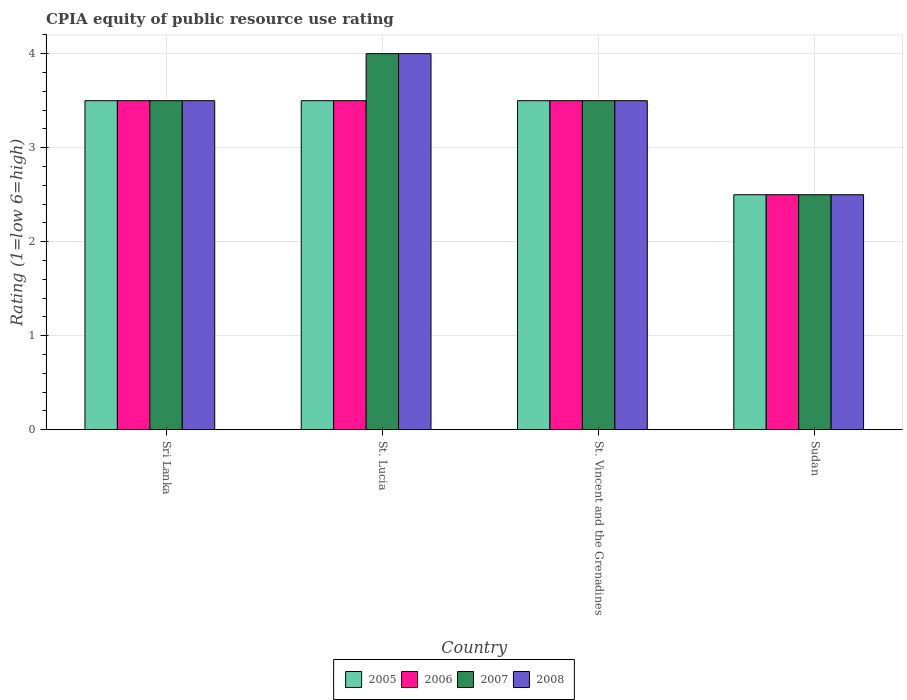How many different coloured bars are there?
Ensure brevity in your answer.  4. What is the label of the 3rd group of bars from the left?
Ensure brevity in your answer.  St. Vincent and the Grenadines. In how many cases, is the number of bars for a given country not equal to the number of legend labels?
Your response must be concise. 0. Across all countries, what is the maximum CPIA rating in 2006?
Offer a very short reply. 3.5. In which country was the CPIA rating in 2006 maximum?
Your answer should be compact. Sri Lanka. In which country was the CPIA rating in 2008 minimum?
Provide a succinct answer. Sudan. What is the total CPIA rating in 2005 in the graph?
Offer a very short reply. 13. What is the difference between the CPIA rating in 2008 in St. Lucia and the CPIA rating in 2007 in Sri Lanka?
Your answer should be very brief. 0.5. What is the average CPIA rating in 2005 per country?
Offer a terse response. 3.25. What is the difference between the highest and the second highest CPIA rating in 2008?
Offer a terse response. -0.5. In how many countries, is the CPIA rating in 2008 greater than the average CPIA rating in 2008 taken over all countries?
Provide a succinct answer. 3. Is it the case that in every country, the sum of the CPIA rating in 2005 and CPIA rating in 2006 is greater than the sum of CPIA rating in 2008 and CPIA rating in 2007?
Ensure brevity in your answer.  No. What does the 3rd bar from the left in Sudan represents?
Your answer should be very brief. 2007. What does the 3rd bar from the right in Sri Lanka represents?
Keep it short and to the point. 2006. Is it the case that in every country, the sum of the CPIA rating in 2007 and CPIA rating in 2008 is greater than the CPIA rating in 2005?
Keep it short and to the point. Yes. Are all the bars in the graph horizontal?
Give a very brief answer. No. How many countries are there in the graph?
Give a very brief answer. 4. What is the difference between two consecutive major ticks on the Y-axis?
Provide a succinct answer. 1. Are the values on the major ticks of Y-axis written in scientific E-notation?
Offer a terse response. No. Does the graph contain any zero values?
Your answer should be very brief. No. Where does the legend appear in the graph?
Ensure brevity in your answer.  Bottom center. How many legend labels are there?
Offer a very short reply. 4. What is the title of the graph?
Make the answer very short. CPIA equity of public resource use rating. What is the label or title of the X-axis?
Provide a succinct answer. Country. What is the Rating (1=low 6=high) in 2008 in Sri Lanka?
Your answer should be compact. 3.5. What is the Rating (1=low 6=high) of 2006 in St. Lucia?
Your response must be concise. 3.5. What is the Rating (1=low 6=high) of 2007 in St. Lucia?
Your response must be concise. 4. What is the Rating (1=low 6=high) in 2006 in St. Vincent and the Grenadines?
Provide a short and direct response. 3.5. What is the Rating (1=low 6=high) of 2007 in St. Vincent and the Grenadines?
Offer a terse response. 3.5. What is the Rating (1=low 6=high) of 2005 in Sudan?
Make the answer very short. 2.5. What is the Rating (1=low 6=high) in 2007 in Sudan?
Offer a very short reply. 2.5. What is the Rating (1=low 6=high) of 2008 in Sudan?
Your answer should be very brief. 2.5. Across all countries, what is the maximum Rating (1=low 6=high) of 2005?
Your answer should be very brief. 3.5. Across all countries, what is the maximum Rating (1=low 6=high) in 2006?
Provide a short and direct response. 3.5. Across all countries, what is the minimum Rating (1=low 6=high) of 2005?
Your answer should be very brief. 2.5. Across all countries, what is the minimum Rating (1=low 6=high) of 2007?
Give a very brief answer. 2.5. Across all countries, what is the minimum Rating (1=low 6=high) of 2008?
Your response must be concise. 2.5. What is the total Rating (1=low 6=high) in 2005 in the graph?
Offer a very short reply. 13. What is the total Rating (1=low 6=high) in 2006 in the graph?
Give a very brief answer. 13. What is the total Rating (1=low 6=high) of 2008 in the graph?
Make the answer very short. 13.5. What is the difference between the Rating (1=low 6=high) of 2005 in Sri Lanka and that in St. Lucia?
Provide a short and direct response. 0. What is the difference between the Rating (1=low 6=high) in 2007 in Sri Lanka and that in St. Lucia?
Offer a terse response. -0.5. What is the difference between the Rating (1=low 6=high) in 2008 in Sri Lanka and that in St. Lucia?
Give a very brief answer. -0.5. What is the difference between the Rating (1=low 6=high) of 2006 in Sri Lanka and that in St. Vincent and the Grenadines?
Your answer should be compact. 0. What is the difference between the Rating (1=low 6=high) of 2008 in Sri Lanka and that in St. Vincent and the Grenadines?
Your response must be concise. 0. What is the difference between the Rating (1=low 6=high) in 2005 in Sri Lanka and that in Sudan?
Provide a short and direct response. 1. What is the difference between the Rating (1=low 6=high) of 2006 in St. Lucia and that in St. Vincent and the Grenadines?
Make the answer very short. 0. What is the difference between the Rating (1=low 6=high) in 2008 in St. Lucia and that in St. Vincent and the Grenadines?
Your answer should be compact. 0.5. What is the difference between the Rating (1=low 6=high) in 2006 in St. Lucia and that in Sudan?
Keep it short and to the point. 1. What is the difference between the Rating (1=low 6=high) in 2007 in St. Lucia and that in Sudan?
Provide a short and direct response. 1.5. What is the difference between the Rating (1=low 6=high) of 2006 in St. Vincent and the Grenadines and that in Sudan?
Provide a succinct answer. 1. What is the difference between the Rating (1=low 6=high) in 2007 in St. Vincent and the Grenadines and that in Sudan?
Offer a very short reply. 1. What is the difference between the Rating (1=low 6=high) in 2008 in St. Vincent and the Grenadines and that in Sudan?
Your response must be concise. 1. What is the difference between the Rating (1=low 6=high) in 2005 in Sri Lanka and the Rating (1=low 6=high) in 2006 in St. Lucia?
Provide a succinct answer. 0. What is the difference between the Rating (1=low 6=high) of 2005 in Sri Lanka and the Rating (1=low 6=high) of 2007 in St. Lucia?
Make the answer very short. -0.5. What is the difference between the Rating (1=low 6=high) in 2005 in Sri Lanka and the Rating (1=low 6=high) in 2008 in St. Lucia?
Your answer should be very brief. -0.5. What is the difference between the Rating (1=low 6=high) of 2006 in Sri Lanka and the Rating (1=low 6=high) of 2007 in St. Lucia?
Your response must be concise. -0.5. What is the difference between the Rating (1=low 6=high) of 2007 in Sri Lanka and the Rating (1=low 6=high) of 2008 in St. Lucia?
Your response must be concise. -0.5. What is the difference between the Rating (1=low 6=high) in 2006 in Sri Lanka and the Rating (1=low 6=high) in 2007 in St. Vincent and the Grenadines?
Your answer should be compact. 0. What is the difference between the Rating (1=low 6=high) in 2007 in Sri Lanka and the Rating (1=low 6=high) in 2008 in St. Vincent and the Grenadines?
Ensure brevity in your answer.  0. What is the difference between the Rating (1=low 6=high) of 2005 in Sri Lanka and the Rating (1=low 6=high) of 2007 in Sudan?
Your response must be concise. 1. What is the difference between the Rating (1=low 6=high) of 2005 in Sri Lanka and the Rating (1=low 6=high) of 2008 in Sudan?
Keep it short and to the point. 1. What is the difference between the Rating (1=low 6=high) in 2006 in Sri Lanka and the Rating (1=low 6=high) in 2008 in Sudan?
Provide a succinct answer. 1. What is the difference between the Rating (1=low 6=high) of 2007 in Sri Lanka and the Rating (1=low 6=high) of 2008 in Sudan?
Offer a terse response. 1. What is the difference between the Rating (1=low 6=high) of 2005 in St. Lucia and the Rating (1=low 6=high) of 2008 in St. Vincent and the Grenadines?
Ensure brevity in your answer.  0. What is the difference between the Rating (1=low 6=high) of 2006 in St. Lucia and the Rating (1=low 6=high) of 2007 in St. Vincent and the Grenadines?
Offer a terse response. 0. What is the difference between the Rating (1=low 6=high) of 2007 in St. Lucia and the Rating (1=low 6=high) of 2008 in St. Vincent and the Grenadines?
Your answer should be very brief. 0.5. What is the difference between the Rating (1=low 6=high) of 2005 in St. Lucia and the Rating (1=low 6=high) of 2006 in Sudan?
Offer a terse response. 1. What is the difference between the Rating (1=low 6=high) in 2005 in St. Vincent and the Grenadines and the Rating (1=low 6=high) in 2006 in Sudan?
Your answer should be very brief. 1. What is the difference between the Rating (1=low 6=high) of 2005 in St. Vincent and the Grenadines and the Rating (1=low 6=high) of 2007 in Sudan?
Offer a terse response. 1. What is the difference between the Rating (1=low 6=high) of 2006 in St. Vincent and the Grenadines and the Rating (1=low 6=high) of 2008 in Sudan?
Give a very brief answer. 1. What is the average Rating (1=low 6=high) in 2006 per country?
Provide a short and direct response. 3.25. What is the average Rating (1=low 6=high) in 2007 per country?
Give a very brief answer. 3.38. What is the average Rating (1=low 6=high) of 2008 per country?
Give a very brief answer. 3.38. What is the difference between the Rating (1=low 6=high) in 2005 and Rating (1=low 6=high) in 2006 in Sri Lanka?
Make the answer very short. 0. What is the difference between the Rating (1=low 6=high) in 2005 and Rating (1=low 6=high) in 2007 in Sri Lanka?
Make the answer very short. 0. What is the difference between the Rating (1=low 6=high) of 2006 and Rating (1=low 6=high) of 2008 in Sri Lanka?
Your answer should be very brief. 0. What is the difference between the Rating (1=low 6=high) in 2007 and Rating (1=low 6=high) in 2008 in Sri Lanka?
Keep it short and to the point. 0. What is the difference between the Rating (1=low 6=high) of 2005 and Rating (1=low 6=high) of 2008 in St. Lucia?
Provide a short and direct response. -0.5. What is the difference between the Rating (1=low 6=high) of 2006 and Rating (1=low 6=high) of 2007 in St. Lucia?
Offer a terse response. -0.5. What is the difference between the Rating (1=low 6=high) in 2007 and Rating (1=low 6=high) in 2008 in St. Vincent and the Grenadines?
Your response must be concise. 0. What is the difference between the Rating (1=low 6=high) of 2005 and Rating (1=low 6=high) of 2007 in Sudan?
Make the answer very short. 0. What is the difference between the Rating (1=low 6=high) in 2006 and Rating (1=low 6=high) in 2007 in Sudan?
Offer a terse response. 0. What is the ratio of the Rating (1=low 6=high) in 2005 in Sri Lanka to that in St. Lucia?
Ensure brevity in your answer.  1. What is the ratio of the Rating (1=low 6=high) in 2007 in Sri Lanka to that in St. Lucia?
Your response must be concise. 0.88. What is the ratio of the Rating (1=low 6=high) in 2006 in Sri Lanka to that in St. Vincent and the Grenadines?
Offer a very short reply. 1. What is the ratio of the Rating (1=low 6=high) in 2007 in Sri Lanka to that in St. Vincent and the Grenadines?
Keep it short and to the point. 1. What is the ratio of the Rating (1=low 6=high) of 2008 in Sri Lanka to that in St. Vincent and the Grenadines?
Offer a very short reply. 1. What is the ratio of the Rating (1=low 6=high) of 2007 in Sri Lanka to that in Sudan?
Your response must be concise. 1.4. What is the ratio of the Rating (1=low 6=high) in 2005 in St. Lucia to that in St. Vincent and the Grenadines?
Provide a short and direct response. 1. What is the ratio of the Rating (1=low 6=high) of 2007 in St. Lucia to that in St. Vincent and the Grenadines?
Ensure brevity in your answer.  1.14. What is the ratio of the Rating (1=low 6=high) in 2008 in St. Lucia to that in St. Vincent and the Grenadines?
Your answer should be compact. 1.14. What is the ratio of the Rating (1=low 6=high) in 2006 in St. Lucia to that in Sudan?
Keep it short and to the point. 1.4. What is the ratio of the Rating (1=low 6=high) of 2008 in St. Lucia to that in Sudan?
Make the answer very short. 1.6. What is the ratio of the Rating (1=low 6=high) of 2006 in St. Vincent and the Grenadines to that in Sudan?
Make the answer very short. 1.4. What is the ratio of the Rating (1=low 6=high) in 2007 in St. Vincent and the Grenadines to that in Sudan?
Offer a very short reply. 1.4. What is the ratio of the Rating (1=low 6=high) in 2008 in St. Vincent and the Grenadines to that in Sudan?
Offer a terse response. 1.4. What is the difference between the highest and the second highest Rating (1=low 6=high) of 2007?
Offer a terse response. 0.5. What is the difference between the highest and the second highest Rating (1=low 6=high) in 2008?
Offer a terse response. 0.5. What is the difference between the highest and the lowest Rating (1=low 6=high) in 2005?
Ensure brevity in your answer.  1. What is the difference between the highest and the lowest Rating (1=low 6=high) in 2006?
Keep it short and to the point. 1. What is the difference between the highest and the lowest Rating (1=low 6=high) in 2008?
Your answer should be very brief. 1.5. 